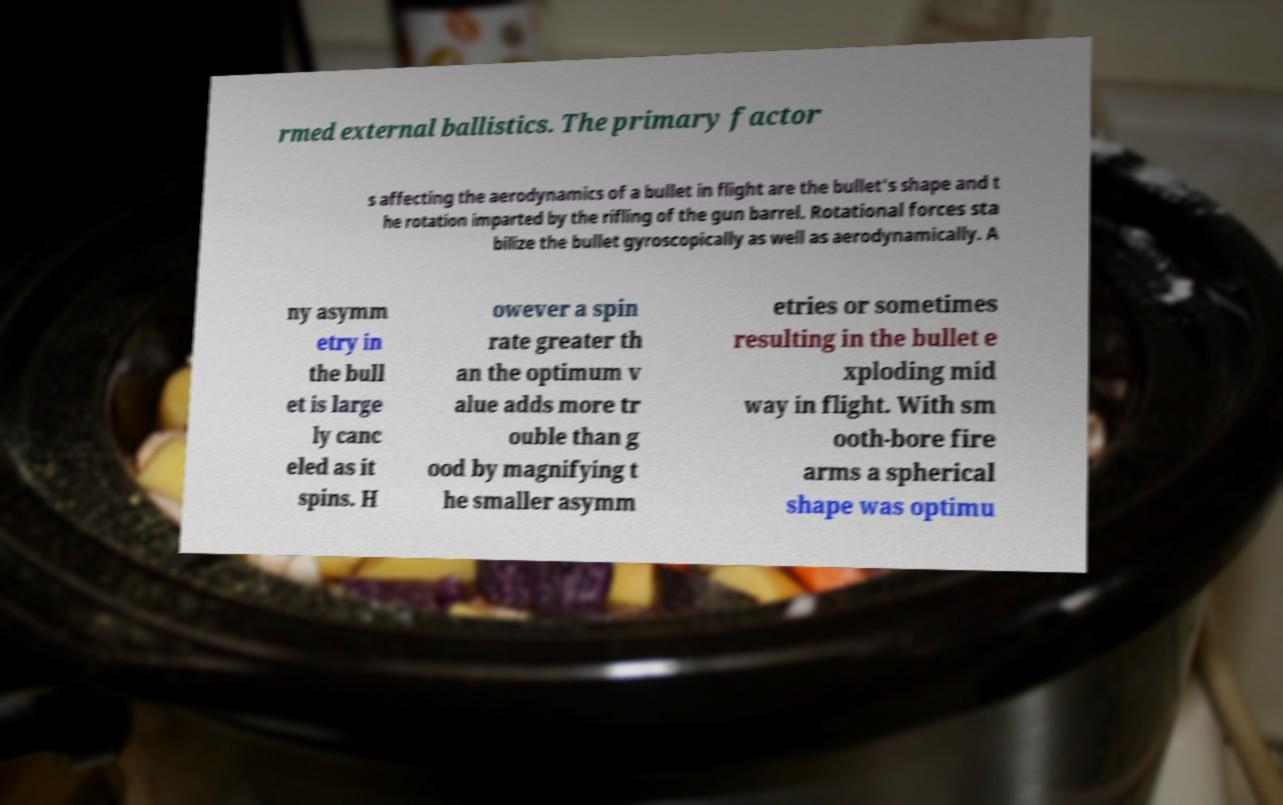I need the written content from this picture converted into text. Can you do that? rmed external ballistics. The primary factor s affecting the aerodynamics of a bullet in flight are the bullet's shape and t he rotation imparted by the rifling of the gun barrel. Rotational forces sta bilize the bullet gyroscopically as well as aerodynamically. A ny asymm etry in the bull et is large ly canc eled as it spins. H owever a spin rate greater th an the optimum v alue adds more tr ouble than g ood by magnifying t he smaller asymm etries or sometimes resulting in the bullet e xploding mid way in flight. With sm ooth-bore fire arms a spherical shape was optimu 